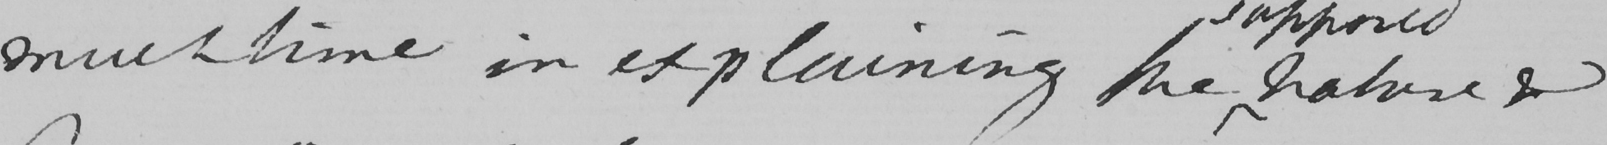Please transcribe the handwritten text in this image. much time in explaining the nature & 